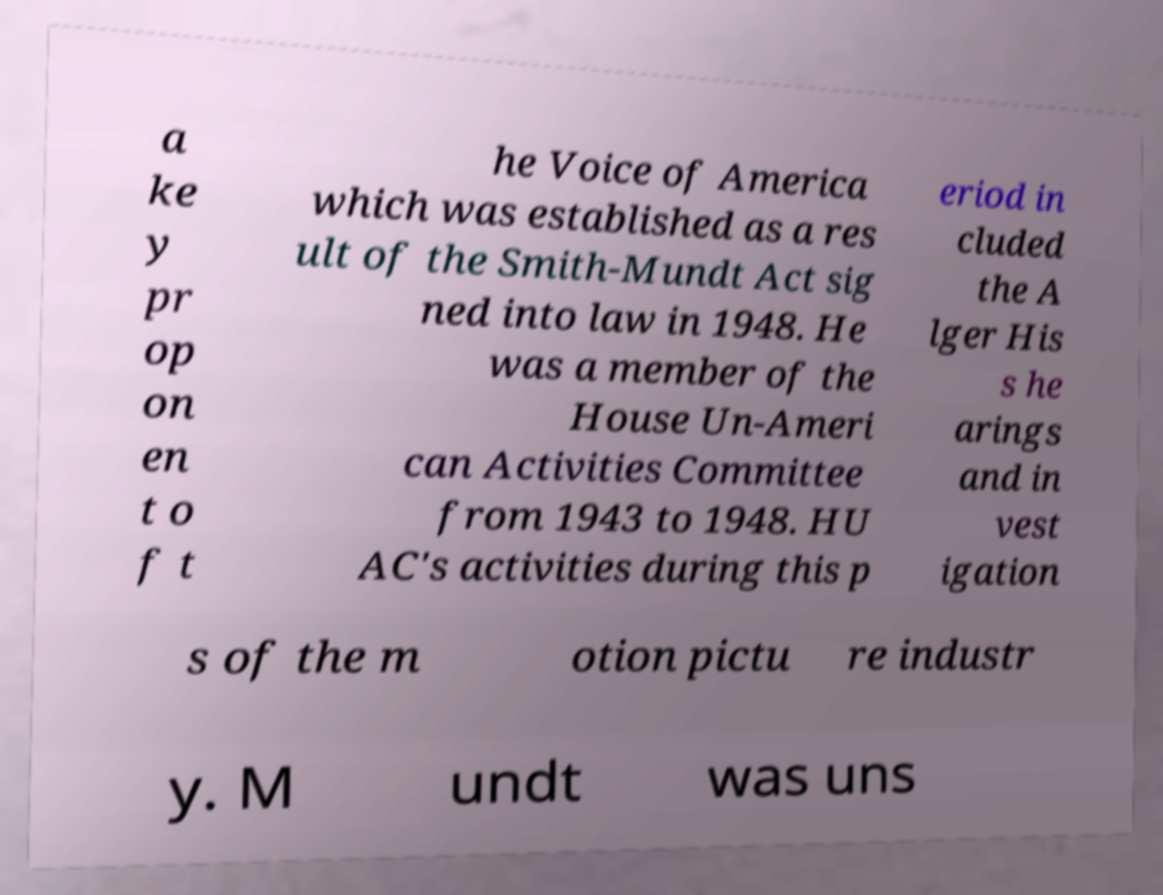I need the written content from this picture converted into text. Can you do that? a ke y pr op on en t o f t he Voice of America which was established as a res ult of the Smith-Mundt Act sig ned into law in 1948. He was a member of the House Un-Ameri can Activities Committee from 1943 to 1948. HU AC's activities during this p eriod in cluded the A lger His s he arings and in vest igation s of the m otion pictu re industr y. M undt was uns 